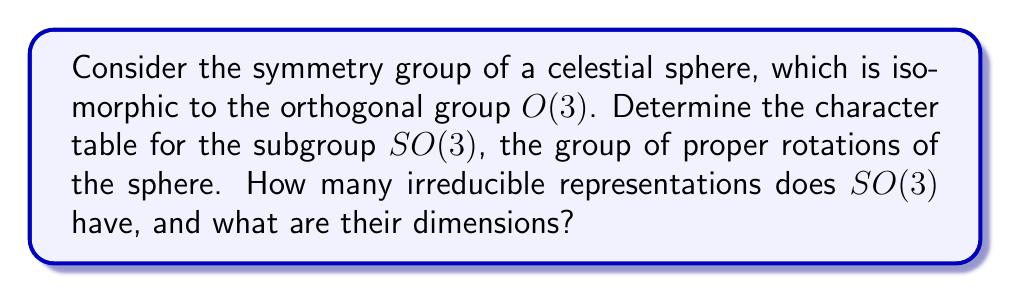Show me your answer to this math problem. To determine the character table for $SO(3)$, we follow these steps:

1) First, recall that $SO(3)$ is a compact Lie group of dimension 3.

2) The conjugacy classes of $SO(3)$ are parameterized by the angle of rotation $\theta \in [0, \pi]$. We have:
   - The identity element (rotation by 0)
   - Rotations by angle $\theta \in (0, \pi)$
   - Rotations by $\pi$

3) The irreducible representations of $SO(3)$ are labeled by non-negative integers $l = 0, 1, 2, \ldots$, corresponding to the angular momentum in physics.

4) The dimension of the irreducible representation labeled by $l$ is $2l + 1$.

5) The character of a rotation by angle $\theta$ in the $l$-th irreducible representation is given by the Chebyshev polynomial:

   $$\chi_l(\theta) = \frac{\sin((l+\frac{1}{2})\theta)}{\sin(\frac{\theta}{2})}$$

6) For the identity element (rotation by 0), the character is always the dimension of the representation: $\chi_l(0) = 2l + 1$.

7) For rotations by $\pi$, the character is $\chi_l(\pi) = (-1)^l(2l + 1)$.

8) The character table for the first few irreducible representations:

   $$\begin{array}{c|ccc}
   SO(3) & e & \text{Rot}(\theta) & \text{Rot}(\pi) \\
   \hline
   D^{(0)} & 1 & 1 & 1 \\
   D^{(1)} & 3 & \frac{\sin(3\theta/2)}{\sin(\theta/2)} & -3 \\
   D^{(2)} & 5 & \frac{\sin(5\theta/2)}{\sin(\theta/2)} & 5 \\
   \vdots & \vdots & \vdots & \vdots
   \end{array}$$

9) $SO(3)$ has infinitely many irreducible representations, one for each non-negative integer $l$.
Answer: $SO(3)$ has infinitely many irreducible representations, with dimensions $2l + 1$ for $l = 0, 1, 2, \ldots$ 